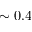Convert formula to latex. <formula><loc_0><loc_0><loc_500><loc_500>\sim 0 . 4</formula> 